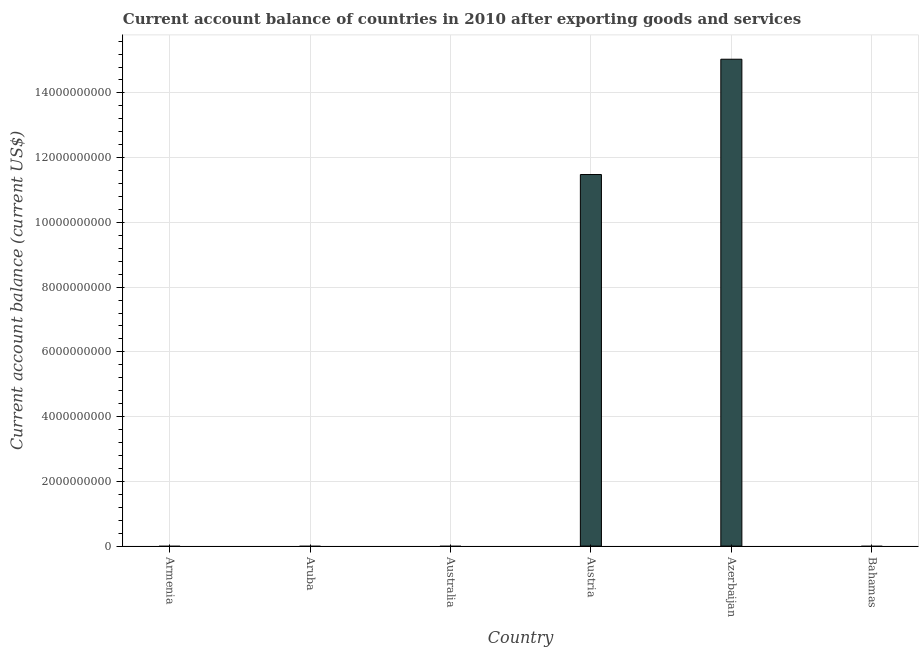Does the graph contain grids?
Give a very brief answer. Yes. What is the title of the graph?
Ensure brevity in your answer.  Current account balance of countries in 2010 after exporting goods and services. What is the label or title of the Y-axis?
Your answer should be compact. Current account balance (current US$). What is the current account balance in Azerbaijan?
Offer a terse response. 1.50e+1. Across all countries, what is the maximum current account balance?
Keep it short and to the point. 1.50e+1. Across all countries, what is the minimum current account balance?
Give a very brief answer. 0. In which country was the current account balance maximum?
Your answer should be compact. Azerbaijan. What is the sum of the current account balance?
Provide a succinct answer. 2.65e+1. What is the difference between the current account balance in Austria and Azerbaijan?
Make the answer very short. -3.56e+09. What is the average current account balance per country?
Give a very brief answer. 4.42e+09. What is the median current account balance?
Provide a succinct answer. 0. Is the sum of the current account balance in Austria and Azerbaijan greater than the maximum current account balance across all countries?
Give a very brief answer. Yes. What is the difference between the highest and the lowest current account balance?
Offer a very short reply. 1.50e+1. In how many countries, is the current account balance greater than the average current account balance taken over all countries?
Provide a short and direct response. 2. Are all the bars in the graph horizontal?
Your answer should be compact. No. What is the Current account balance (current US$) in Aruba?
Give a very brief answer. 0. What is the Current account balance (current US$) of Austria?
Offer a very short reply. 1.15e+1. What is the Current account balance (current US$) in Azerbaijan?
Offer a terse response. 1.50e+1. What is the difference between the Current account balance (current US$) in Austria and Azerbaijan?
Make the answer very short. -3.56e+09. What is the ratio of the Current account balance (current US$) in Austria to that in Azerbaijan?
Your answer should be compact. 0.76. 